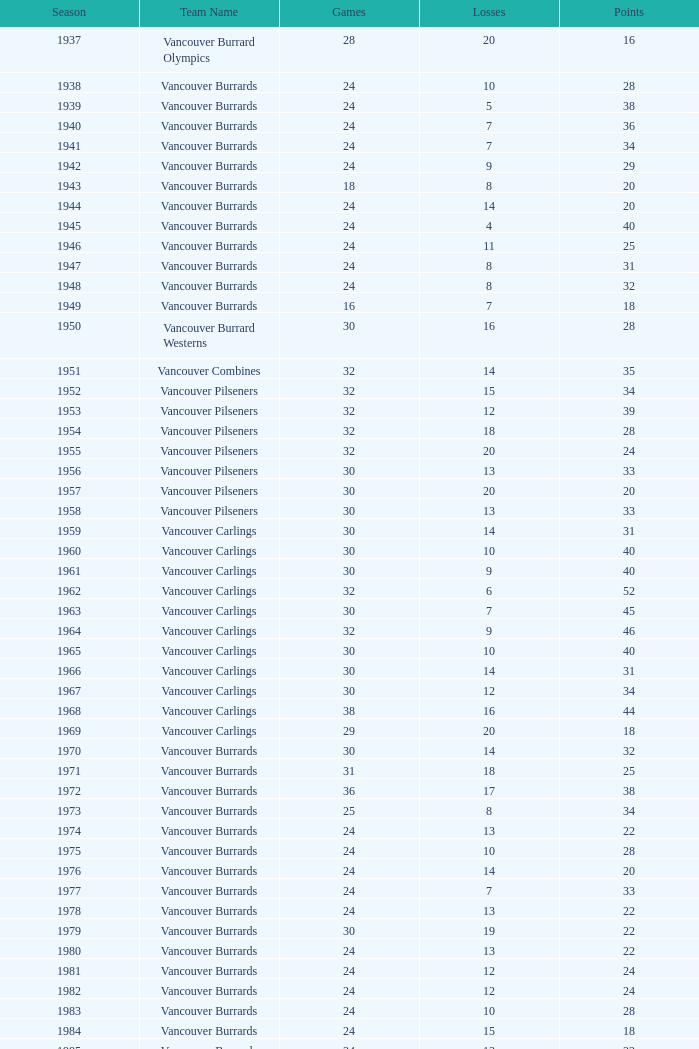What's the total number of games with more than 20 points for the 1976 season? 0.0. 